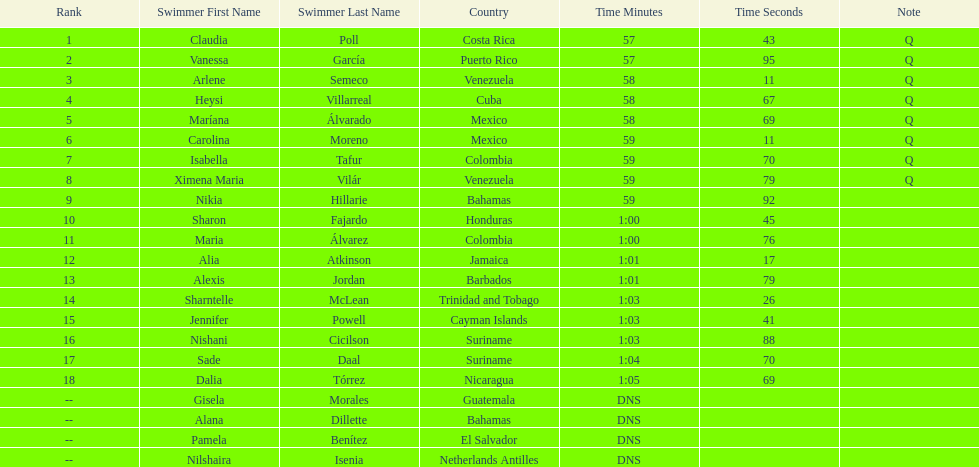How many swimmers did not swim? 4. 